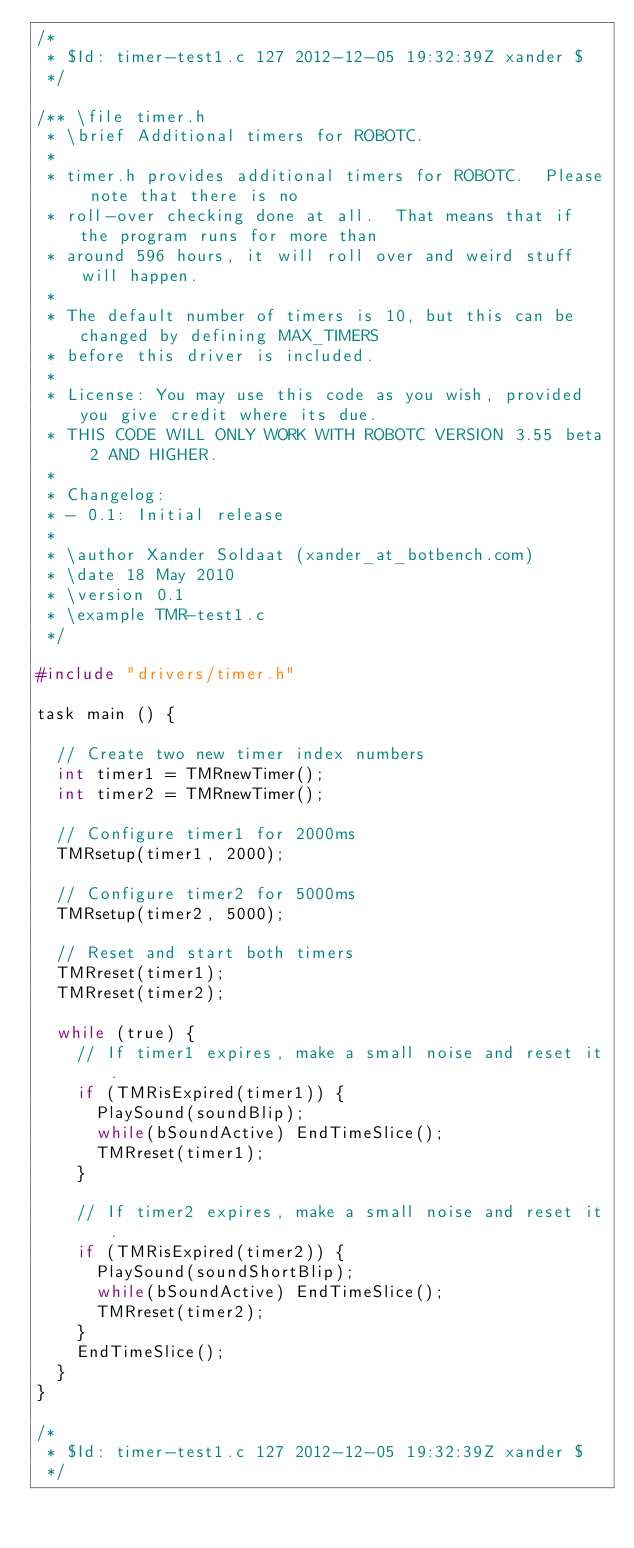<code> <loc_0><loc_0><loc_500><loc_500><_C_>/*
 * $Id: timer-test1.c 127 2012-12-05 19:32:39Z xander $
 */

/** \file timer.h
 * \brief Additional timers for ROBOTC.
 *
 * timer.h provides additional timers for ROBOTC.  Please note that there is no
 * roll-over checking done at all.  That means that if the program runs for more than
 * around 596 hours, it will roll over and weird stuff will happen.
 *
 * The default number of timers is 10, but this can be changed by defining MAX_TIMERS
 * before this driver is included.
 *
 * License: You may use this code as you wish, provided you give credit where its due.
 * THIS CODE WILL ONLY WORK WITH ROBOTC VERSION 3.55 beta 2 AND HIGHER.
 *
 * Changelog:
 * - 0.1: Initial release
 *
 * \author Xander Soldaat (xander_at_botbench.com)
 * \date 18 May 2010
 * \version 0.1
 * \example TMR-test1.c
 */

#include "drivers/timer.h"

task main () {

  // Create two new timer index numbers
  int timer1 = TMRnewTimer();
  int timer2 = TMRnewTimer();

  // Configure timer1 for 2000ms
  TMRsetup(timer1, 2000);

  // Configure timer2 for 5000ms
  TMRsetup(timer2, 5000);

  // Reset and start both timers
  TMRreset(timer1);
  TMRreset(timer2);

  while (true) {
    // If timer1 expires, make a small noise and reset it.
    if (TMRisExpired(timer1)) {
      PlaySound(soundBlip);
      while(bSoundActive) EndTimeSlice();
      TMRreset(timer1);
    }

    // If timer2 expires, make a small noise and reset it.
    if (TMRisExpired(timer2)) {
      PlaySound(soundShortBlip);
      while(bSoundActive) EndTimeSlice();
      TMRreset(timer2);
    }
    EndTimeSlice();
  }
}

/*
 * $Id: timer-test1.c 127 2012-12-05 19:32:39Z xander $
 */
</code> 